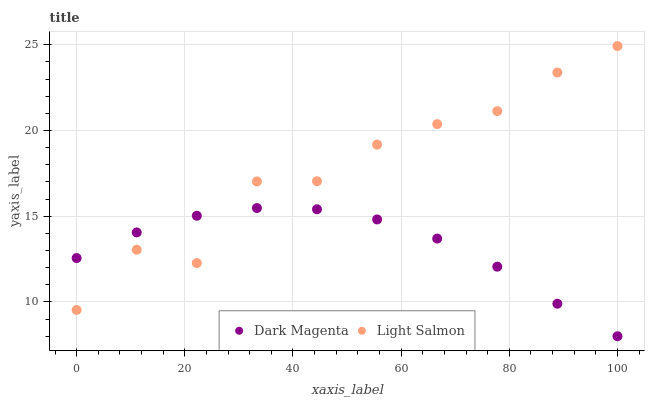Does Dark Magenta have the minimum area under the curve?
Answer yes or no. Yes. Does Light Salmon have the maximum area under the curve?
Answer yes or no. Yes. Does Dark Magenta have the maximum area under the curve?
Answer yes or no. No. Is Dark Magenta the smoothest?
Answer yes or no. Yes. Is Light Salmon the roughest?
Answer yes or no. Yes. Is Dark Magenta the roughest?
Answer yes or no. No. Does Dark Magenta have the lowest value?
Answer yes or no. Yes. Does Light Salmon have the highest value?
Answer yes or no. Yes. Does Dark Magenta have the highest value?
Answer yes or no. No. Does Light Salmon intersect Dark Magenta?
Answer yes or no. Yes. Is Light Salmon less than Dark Magenta?
Answer yes or no. No. Is Light Salmon greater than Dark Magenta?
Answer yes or no. No. 